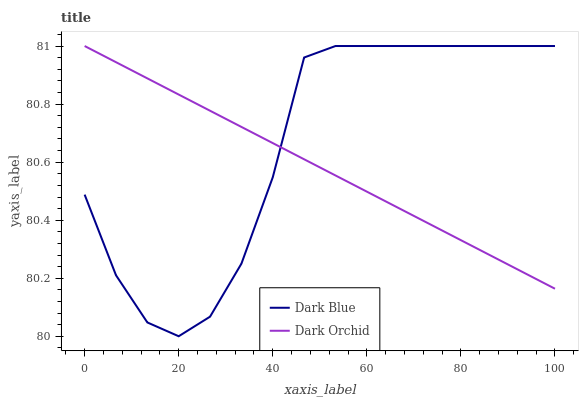Does Dark Orchid have the minimum area under the curve?
Answer yes or no. Yes. Does Dark Blue have the maximum area under the curve?
Answer yes or no. Yes. Does Dark Orchid have the maximum area under the curve?
Answer yes or no. No. Is Dark Orchid the smoothest?
Answer yes or no. Yes. Is Dark Blue the roughest?
Answer yes or no. Yes. Is Dark Orchid the roughest?
Answer yes or no. No. Does Dark Blue have the lowest value?
Answer yes or no. Yes. Does Dark Orchid have the lowest value?
Answer yes or no. No. Does Dark Orchid have the highest value?
Answer yes or no. Yes. Does Dark Blue intersect Dark Orchid?
Answer yes or no. Yes. Is Dark Blue less than Dark Orchid?
Answer yes or no. No. Is Dark Blue greater than Dark Orchid?
Answer yes or no. No. 